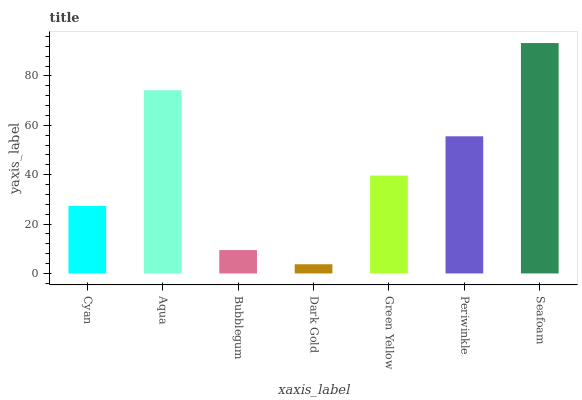Is Dark Gold the minimum?
Answer yes or no. Yes. Is Seafoam the maximum?
Answer yes or no. Yes. Is Aqua the minimum?
Answer yes or no. No. Is Aqua the maximum?
Answer yes or no. No. Is Aqua greater than Cyan?
Answer yes or no. Yes. Is Cyan less than Aqua?
Answer yes or no. Yes. Is Cyan greater than Aqua?
Answer yes or no. No. Is Aqua less than Cyan?
Answer yes or no. No. Is Green Yellow the high median?
Answer yes or no. Yes. Is Green Yellow the low median?
Answer yes or no. Yes. Is Bubblegum the high median?
Answer yes or no. No. Is Dark Gold the low median?
Answer yes or no. No. 